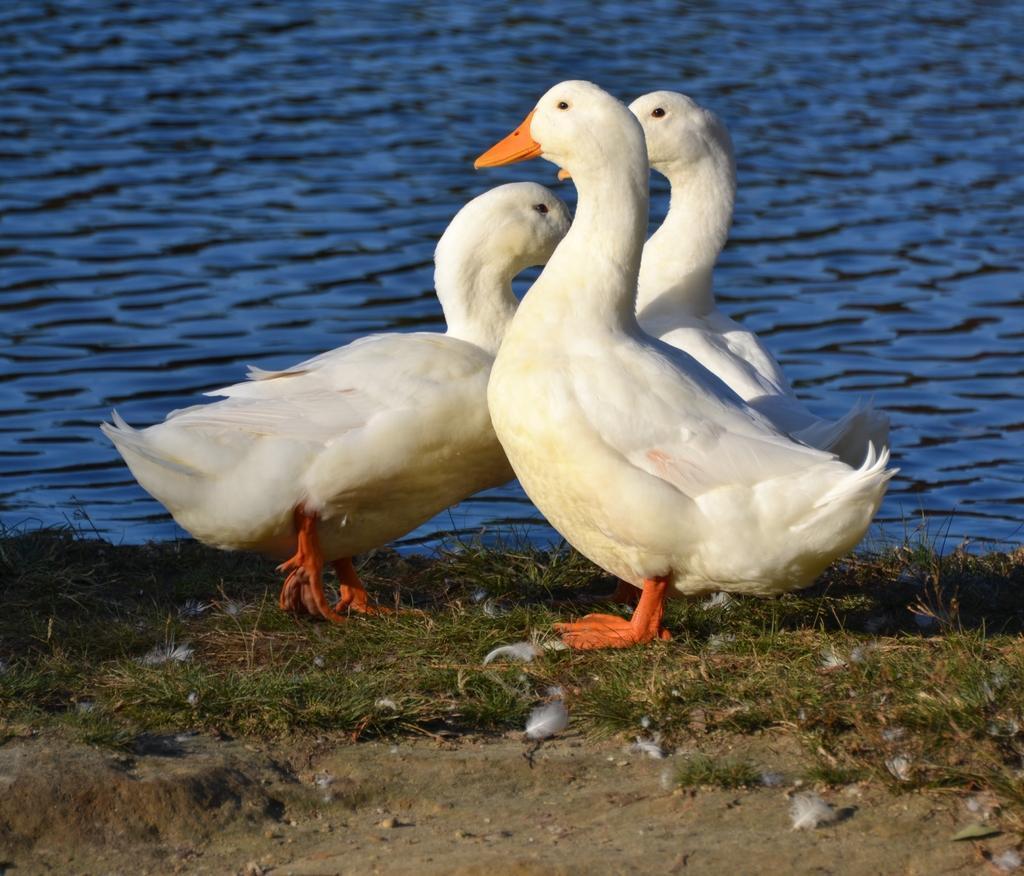Please provide a concise description of this image. In this image there are three white ducks on the ground. Behind them there is water. On the ground there is grass and sand. 